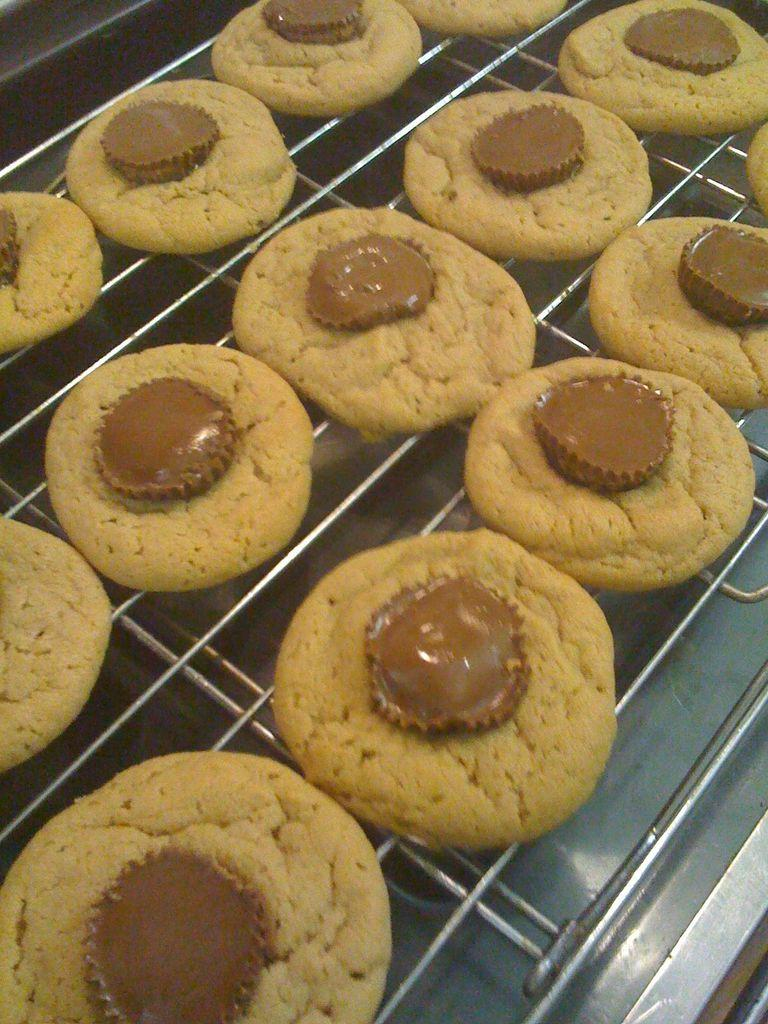What is being cooked on the grill in the image? There are cookies on a grill in the image. Can you describe the person in the image? There is a girl in the image. What is the girl standing on in the image? There is a platform under the girl. What type of experience does the girl have with anger management in the image? There is no indication of the girl's experience with anger management in the image. How many people are present in the image? The image only shows one person, the girl. 